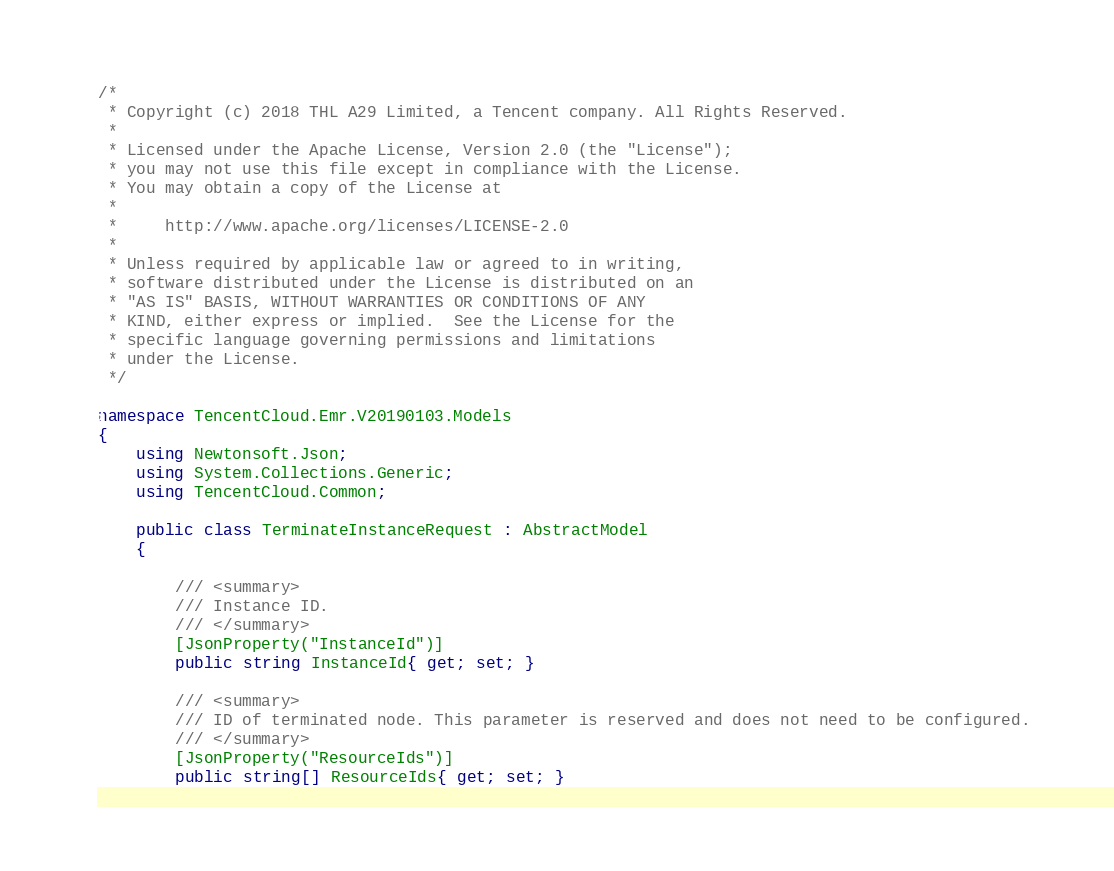<code> <loc_0><loc_0><loc_500><loc_500><_C#_>/*
 * Copyright (c) 2018 THL A29 Limited, a Tencent company. All Rights Reserved.
 *
 * Licensed under the Apache License, Version 2.0 (the "License");
 * you may not use this file except in compliance with the License.
 * You may obtain a copy of the License at
 *
 *     http://www.apache.org/licenses/LICENSE-2.0
 *
 * Unless required by applicable law or agreed to in writing,
 * software distributed under the License is distributed on an
 * "AS IS" BASIS, WITHOUT WARRANTIES OR CONDITIONS OF ANY
 * KIND, either express or implied.  See the License for the
 * specific language governing permissions and limitations
 * under the License.
 */

namespace TencentCloud.Emr.V20190103.Models
{
    using Newtonsoft.Json;
    using System.Collections.Generic;
    using TencentCloud.Common;

    public class TerminateInstanceRequest : AbstractModel
    {
        
        /// <summary>
        /// Instance ID.
        /// </summary>
        [JsonProperty("InstanceId")]
        public string InstanceId{ get; set; }

        /// <summary>
        /// ID of terminated node. This parameter is reserved and does not need to be configured.
        /// </summary>
        [JsonProperty("ResourceIds")]
        public string[] ResourceIds{ get; set; }

</code> 